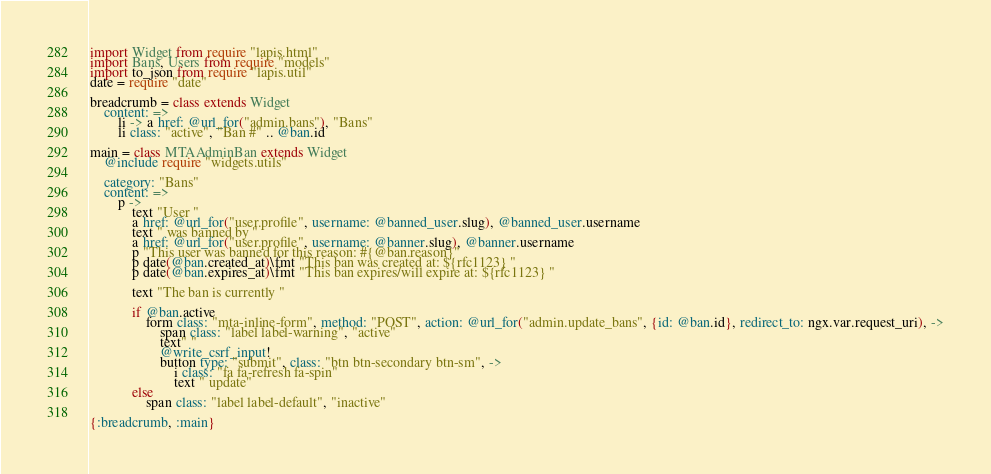Convert code to text. <code><loc_0><loc_0><loc_500><loc_500><_MoonScript_>import Widget from require "lapis.html"
import Bans, Users from require "models"
import to_json from require "lapis.util"
date = require "date"

breadcrumb = class extends Widget
	content: =>
		li -> a href: @url_for("admin.bans"), "Bans"
		li class: "active", "Ban #" .. @ban.id

main = class MTAAdminBan extends Widget
	@include require "widgets.utils"

	category: "Bans"
	content: =>
		p ->
			text "User "
			a href: @url_for("user.profile", username: @banned_user.slug), @banned_user.username
			text " was banned by "
			a href: @url_for("user.profile", username: @banner.slug), @banner.username
			p "This user was banned for this reason: #{@ban.reason}"
			p date(@ban.created_at)\fmt "This ban was created at: ${rfc1123} "
			p date(@ban.expires_at)\fmt "This ban expires/will expire at: ${rfc1123} "

			text "The ban is currently "
				
			if @ban.active
				form class: "mta-inline-form", method: "POST", action: @url_for("admin.update_bans", {id: @ban.id}, redirect_to: ngx.var.request_uri), ->
					span class: "label label-warning", "active"
					text" "
					@write_csrf_input!
					button type: "submit", class: "btn btn-secondary btn-sm", ->
						i class: "fa fa-refresh fa-spin"
						text " update"
			else
				span class: "label label-default", "inactive"

{:breadcrumb, :main}</code> 